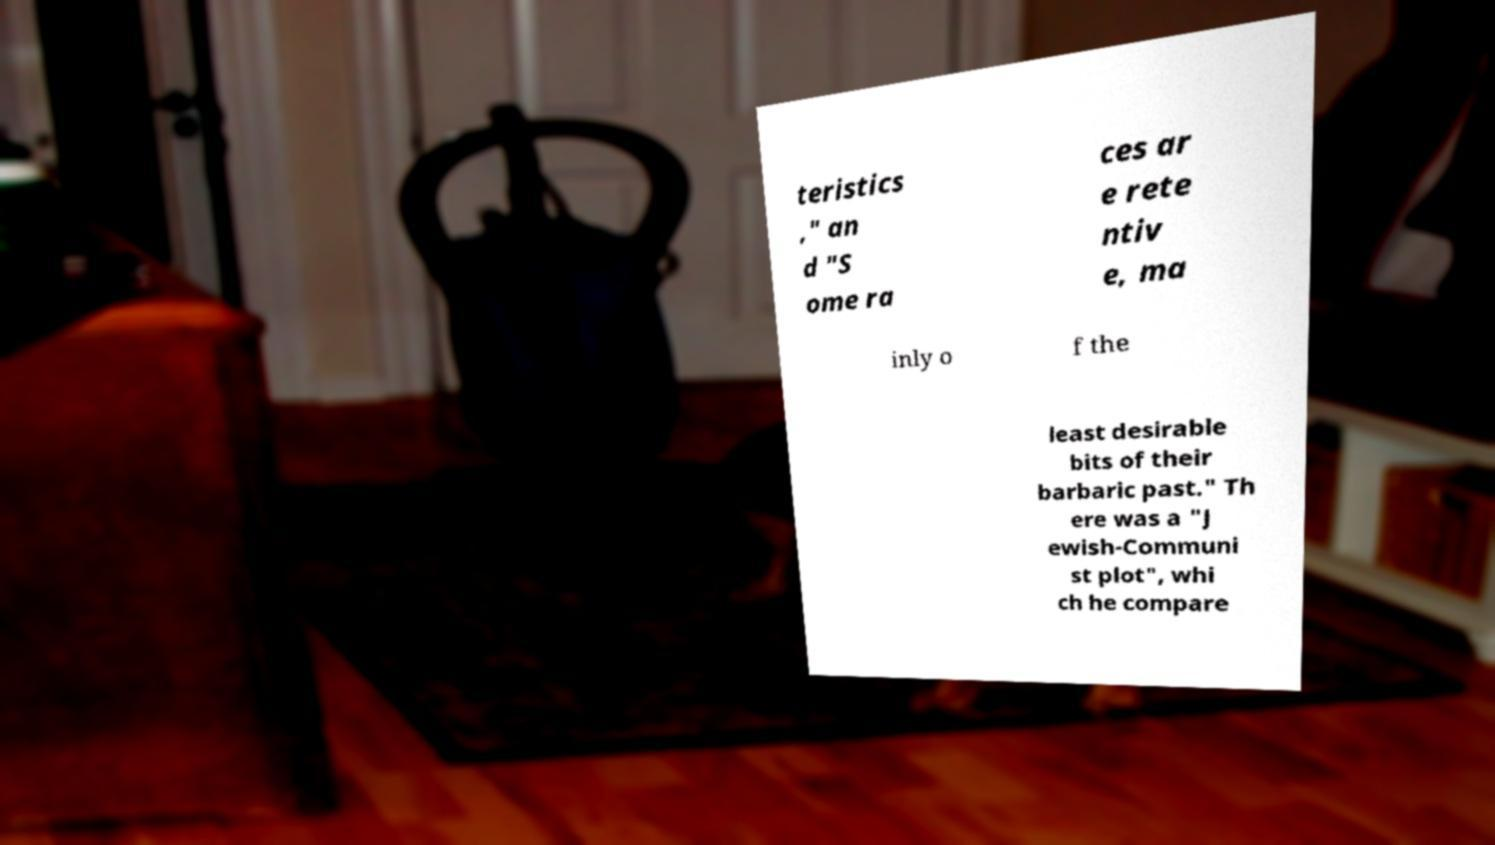Can you read and provide the text displayed in the image?This photo seems to have some interesting text. Can you extract and type it out for me? teristics ," an d "S ome ra ces ar e rete ntiv e, ma inly o f the least desirable bits of their barbaric past." Th ere was a "J ewish-Communi st plot", whi ch he compare 